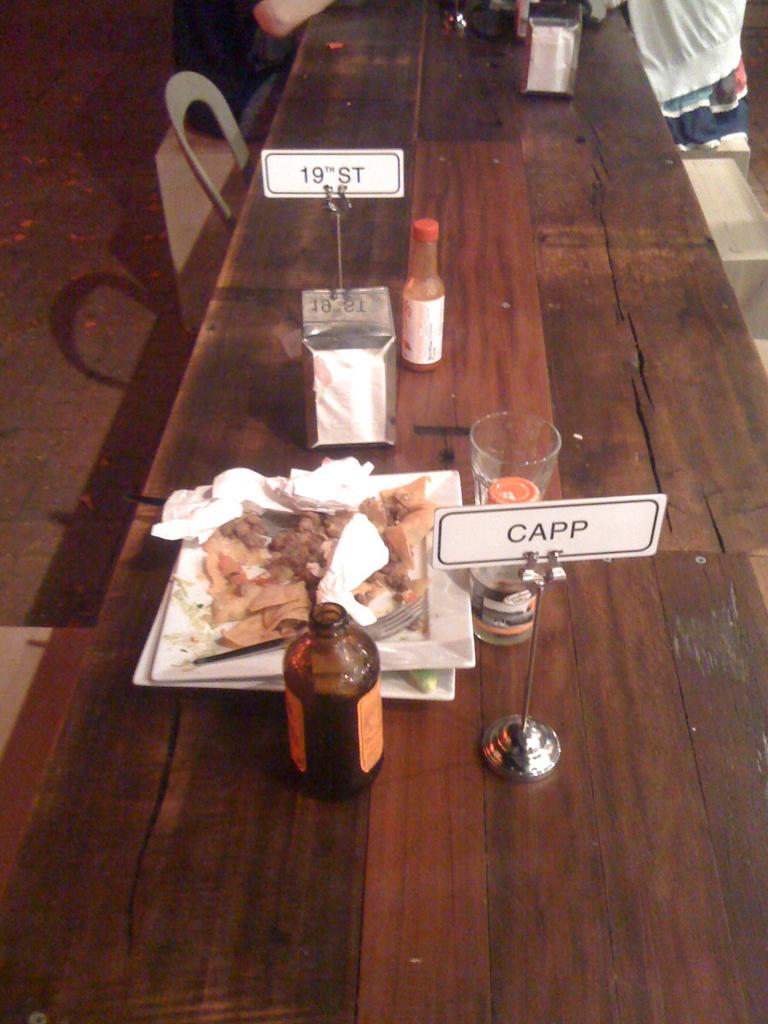What name is on the closest card?
Ensure brevity in your answer.  Capp. 